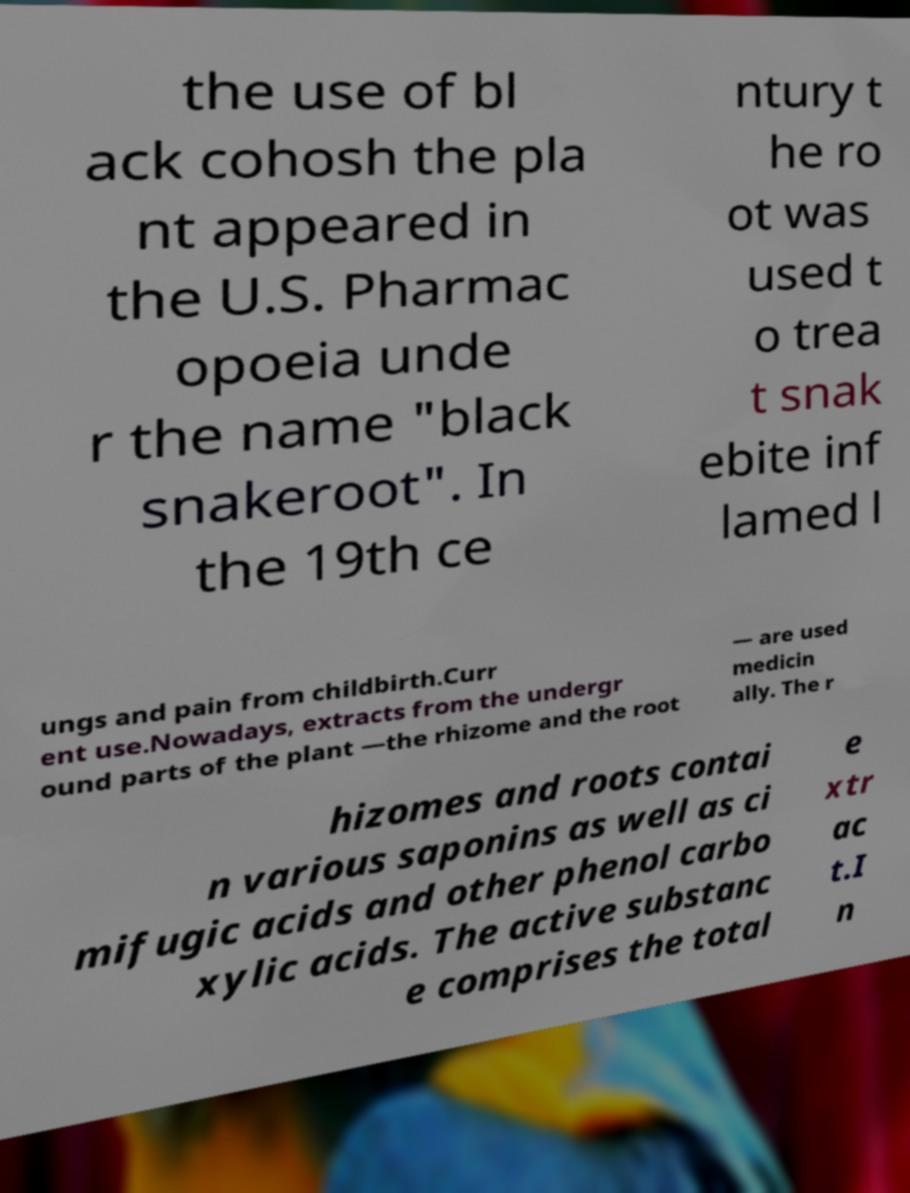Could you assist in decoding the text presented in this image and type it out clearly? the use of bl ack cohosh the pla nt appeared in the U.S. Pharmac opoeia unde r the name "black snakeroot". In the 19th ce ntury t he ro ot was used t o trea t snak ebite inf lamed l ungs and pain from childbirth.Curr ent use.Nowadays, extracts from the undergr ound parts of the plant —the rhizome and the root — are used medicin ally. The r hizomes and roots contai n various saponins as well as ci mifugic acids and other phenol carbo xylic acids. The active substanc e comprises the total e xtr ac t.I n 